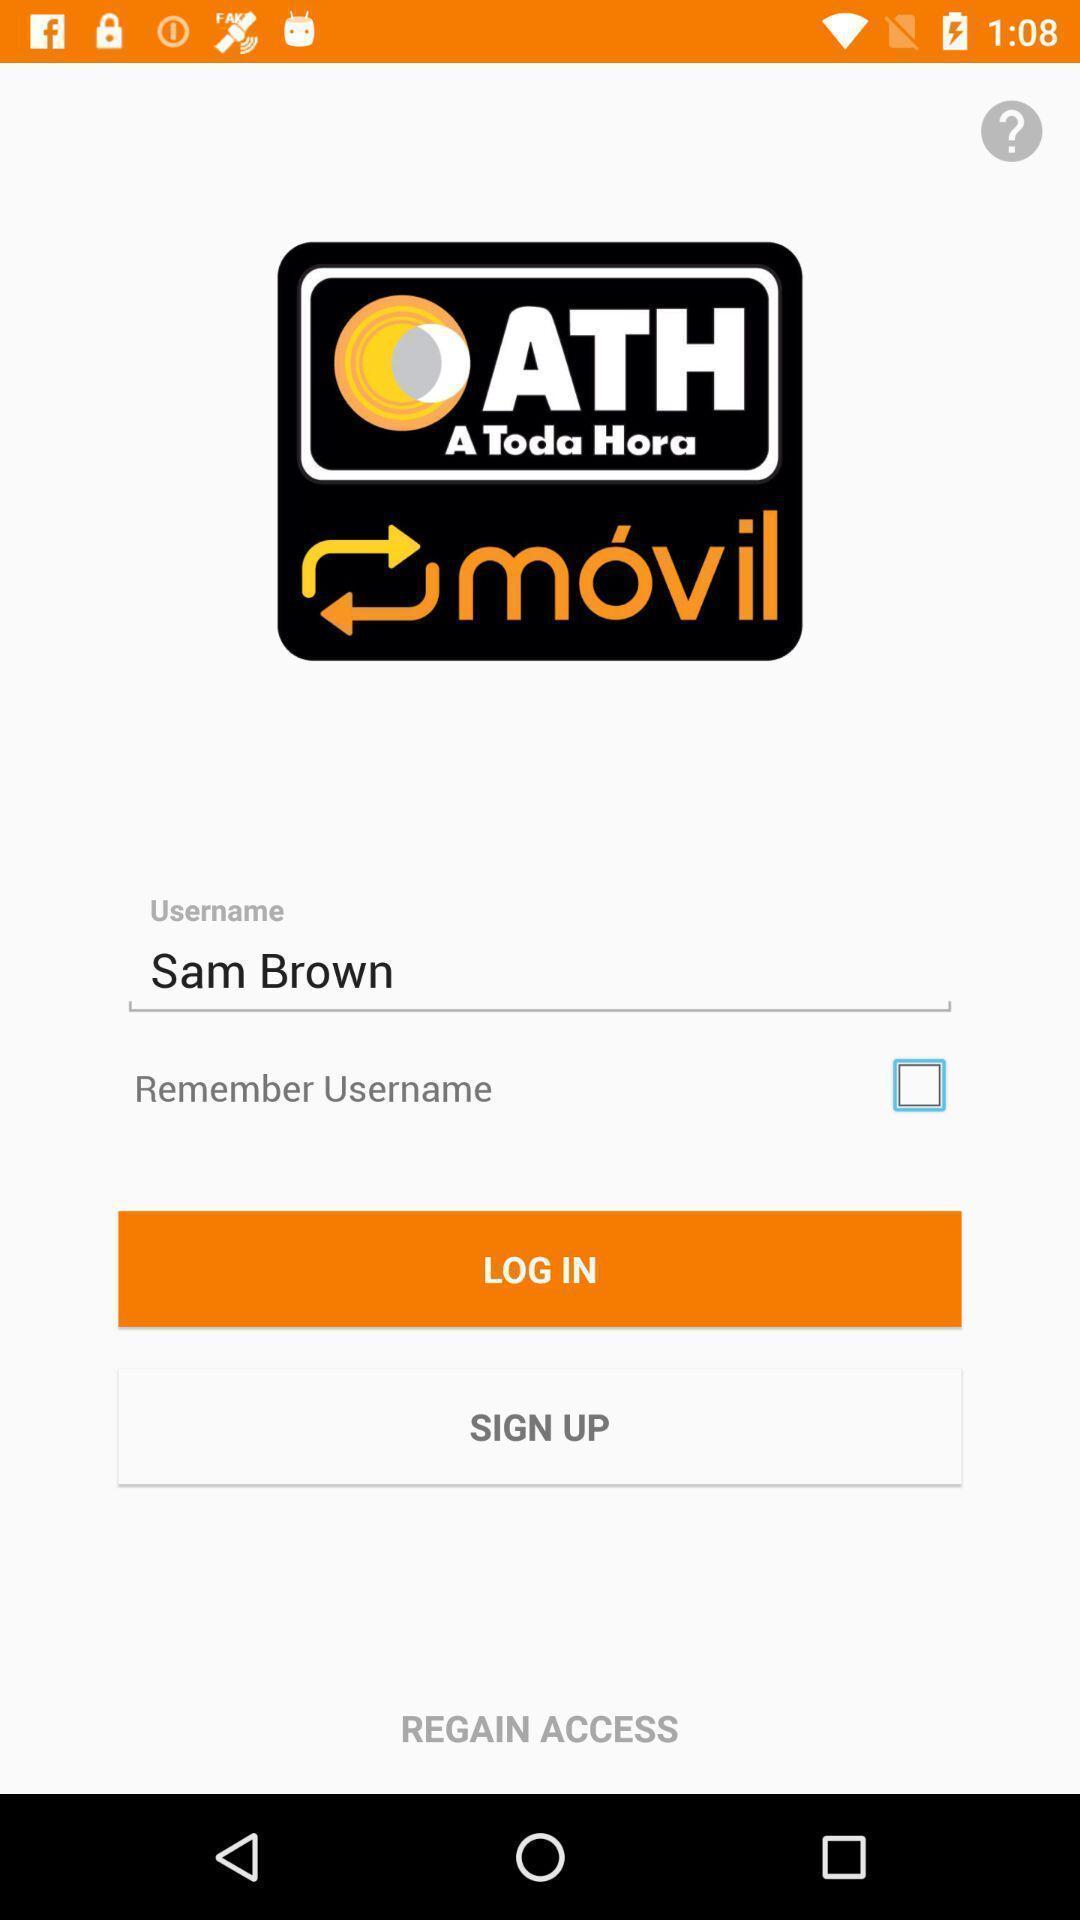Summarize the information in this screenshot. Page displaying signing in information about an application. 